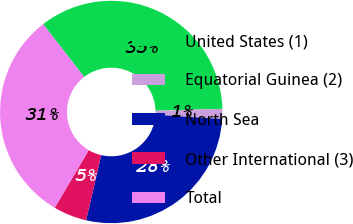<chart> <loc_0><loc_0><loc_500><loc_500><pie_chart><fcel>United States (1)<fcel>Equatorial Guinea (2)<fcel>North Sea<fcel>Other International (3)<fcel>Total<nl><fcel>35.05%<fcel>1.46%<fcel>27.63%<fcel>4.85%<fcel>31.02%<nl></chart> 